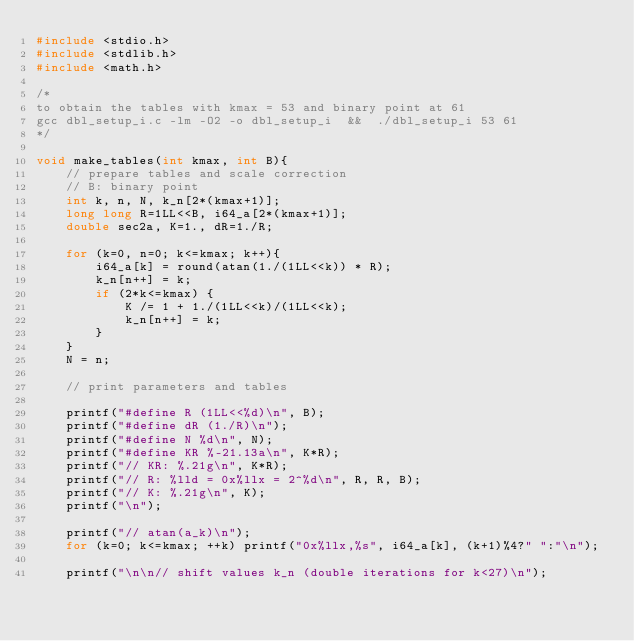<code> <loc_0><loc_0><loc_500><loc_500><_C_>#include <stdio.h>
#include <stdlib.h>
#include <math.h>

/*
to obtain the tables with kmax = 53 and binary point at 61
gcc dbl_setup_i.c -lm -O2 -o dbl_setup_i  &&  ./dbl_setup_i 53 61
*/

void make_tables(int kmax, int B){
    // prepare tables and scale correction
    // B: binary point
    int k, n, N, k_n[2*(kmax+1)];
    long long R=1LL<<B, i64_a[2*(kmax+1)];
    double sec2a, K=1., dR=1./R;

    for (k=0, n=0; k<=kmax; k++){
        i64_a[k] = round(atan(1./(1LL<<k)) * R);
        k_n[n++] = k;
        if (2*k<=kmax) {
            K /= 1 + 1./(1LL<<k)/(1LL<<k);
            k_n[n++] = k;
        }
    }
    N = n;

    // print parameters and tables

    printf("#define R (1LL<<%d)\n", B);
    printf("#define dR (1./R)\n");
    printf("#define N %d\n", N);
    printf("#define KR %-21.13a\n", K*R);
    printf("// KR: %.21g\n", K*R);
    printf("// R: %lld = 0x%llx = 2^%d\n", R, R, B);
    printf("// K: %.21g\n", K);
    printf("\n");

    printf("// atan(a_k)\n");
    for (k=0; k<=kmax; ++k) printf("0x%llx,%s", i64_a[k], (k+1)%4?" ":"\n");

    printf("\n\n// shift values k_n (double iterations for k<27)\n");</code> 